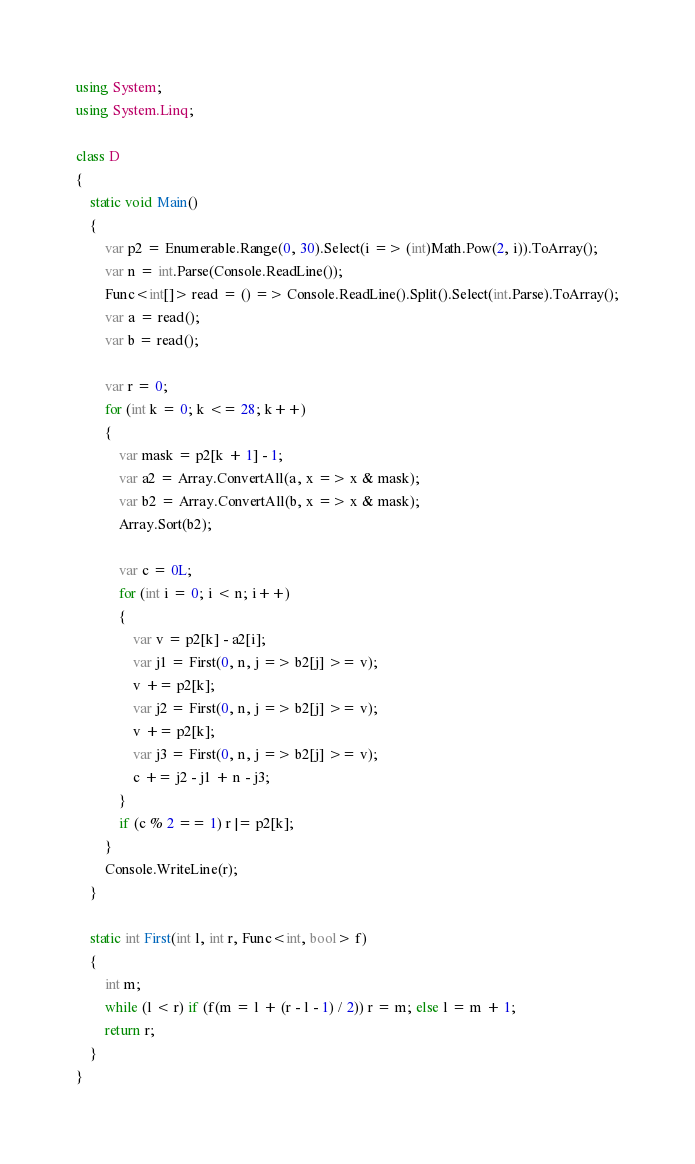Convert code to text. <code><loc_0><loc_0><loc_500><loc_500><_C#_>using System;
using System.Linq;

class D
{
	static void Main()
	{
		var p2 = Enumerable.Range(0, 30).Select(i => (int)Math.Pow(2, i)).ToArray();
		var n = int.Parse(Console.ReadLine());
		Func<int[]> read = () => Console.ReadLine().Split().Select(int.Parse).ToArray();
		var a = read();
		var b = read();

		var r = 0;
		for (int k = 0; k <= 28; k++)
		{
			var mask = p2[k + 1] - 1;
			var a2 = Array.ConvertAll(a, x => x & mask);
			var b2 = Array.ConvertAll(b, x => x & mask);
			Array.Sort(b2);

			var c = 0L;
			for (int i = 0; i < n; i++)
			{
				var v = p2[k] - a2[i];
				var j1 = First(0, n, j => b2[j] >= v);
				v += p2[k];
				var j2 = First(0, n, j => b2[j] >= v);
				v += p2[k];
				var j3 = First(0, n, j => b2[j] >= v);
				c += j2 - j1 + n - j3;
			}
			if (c % 2 == 1) r |= p2[k];
		}
		Console.WriteLine(r);
	}

	static int First(int l, int r, Func<int, bool> f)
	{
		int m;
		while (l < r) if (f(m = l + (r - l - 1) / 2)) r = m; else l = m + 1;
		return r;
	}
}
</code> 